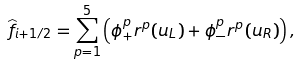<formula> <loc_0><loc_0><loc_500><loc_500>\widehat { f } _ { i + 1 / 2 } = \sum _ { p = 1 } ^ { 5 } \left ( \phi ^ { p } _ { + } { r } ^ { p } ( { u } _ { L } ) + \phi ^ { p } _ { - } { r } ^ { p } ( { u } _ { R } ) \right ) ,</formula> 